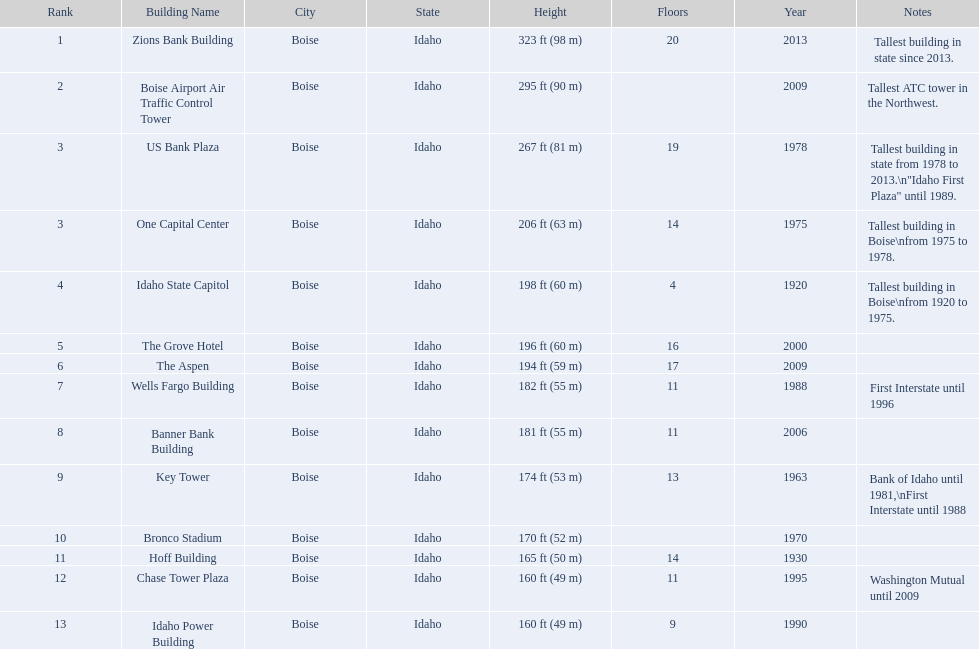Which building has the most floors according to this chart? Zions Bank Building. 